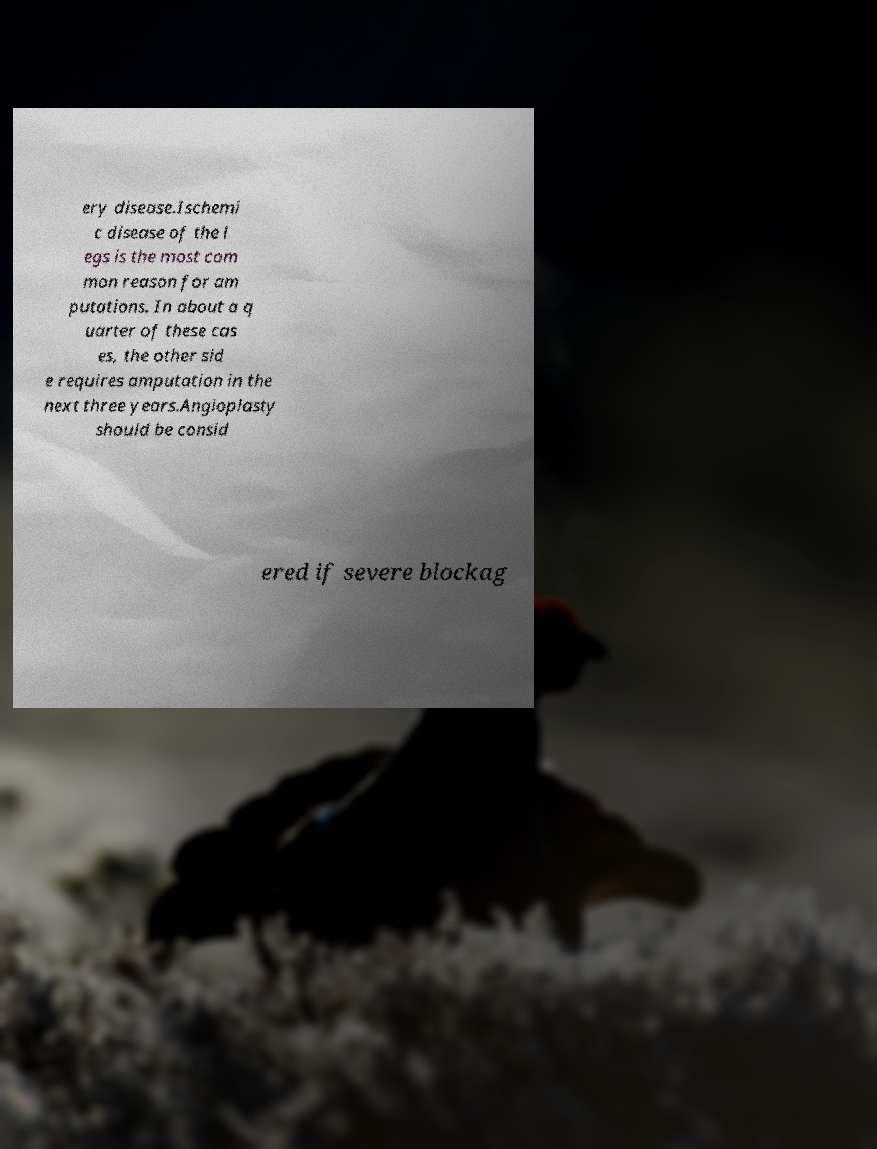Could you assist in decoding the text presented in this image and type it out clearly? ery disease.Ischemi c disease of the l egs is the most com mon reason for am putations. In about a q uarter of these cas es, the other sid e requires amputation in the next three years.Angioplasty should be consid ered if severe blockag 